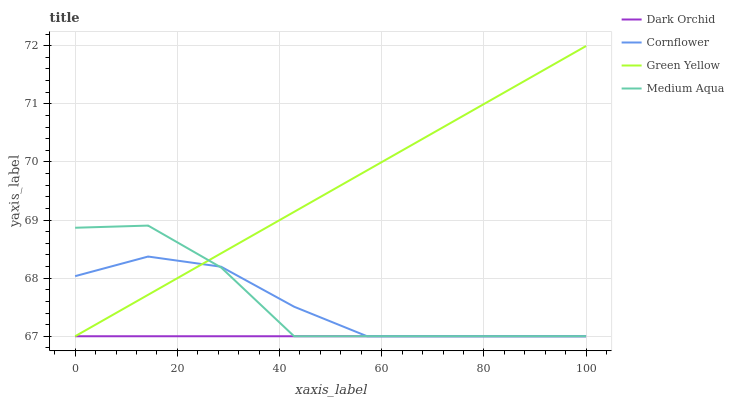Does Dark Orchid have the minimum area under the curve?
Answer yes or no. Yes. Does Green Yellow have the maximum area under the curve?
Answer yes or no. Yes. Does Medium Aqua have the minimum area under the curve?
Answer yes or no. No. Does Medium Aqua have the maximum area under the curve?
Answer yes or no. No. Is Dark Orchid the smoothest?
Answer yes or no. Yes. Is Medium Aqua the roughest?
Answer yes or no. Yes. Is Green Yellow the smoothest?
Answer yes or no. No. Is Green Yellow the roughest?
Answer yes or no. No. Does Cornflower have the lowest value?
Answer yes or no. Yes. Does Green Yellow have the highest value?
Answer yes or no. Yes. Does Medium Aqua have the highest value?
Answer yes or no. No. Does Green Yellow intersect Dark Orchid?
Answer yes or no. Yes. Is Green Yellow less than Dark Orchid?
Answer yes or no. No. Is Green Yellow greater than Dark Orchid?
Answer yes or no. No. 